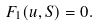<formula> <loc_0><loc_0><loc_500><loc_500>F _ { 1 } ( u , S ) = 0 .</formula> 